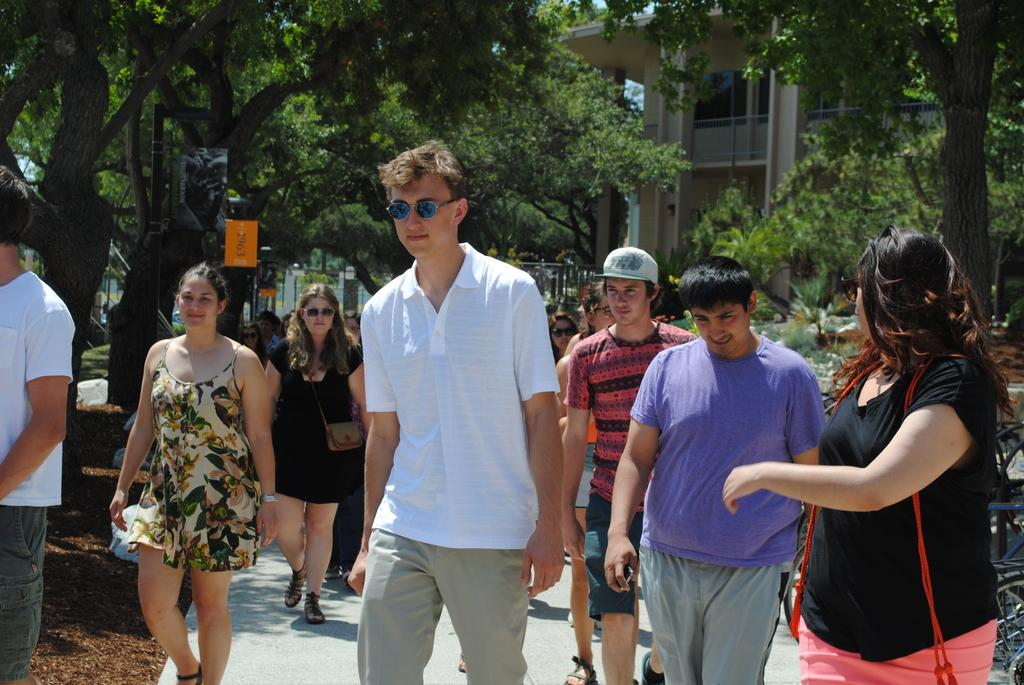What are the people in the image doing? There are people walking on a path in the image. What can be seen in the background of the image? There are trees and buildings in the background of the image. How many plantations can be seen in the image? There are no plantations present in the image. What type of look or expression do the people have in the image? The provided facts do not mention the people's expressions or looks. What type of behavior can be observed in the people in the image? The provided facts do not mention any specific behaviors of the people in the image. 